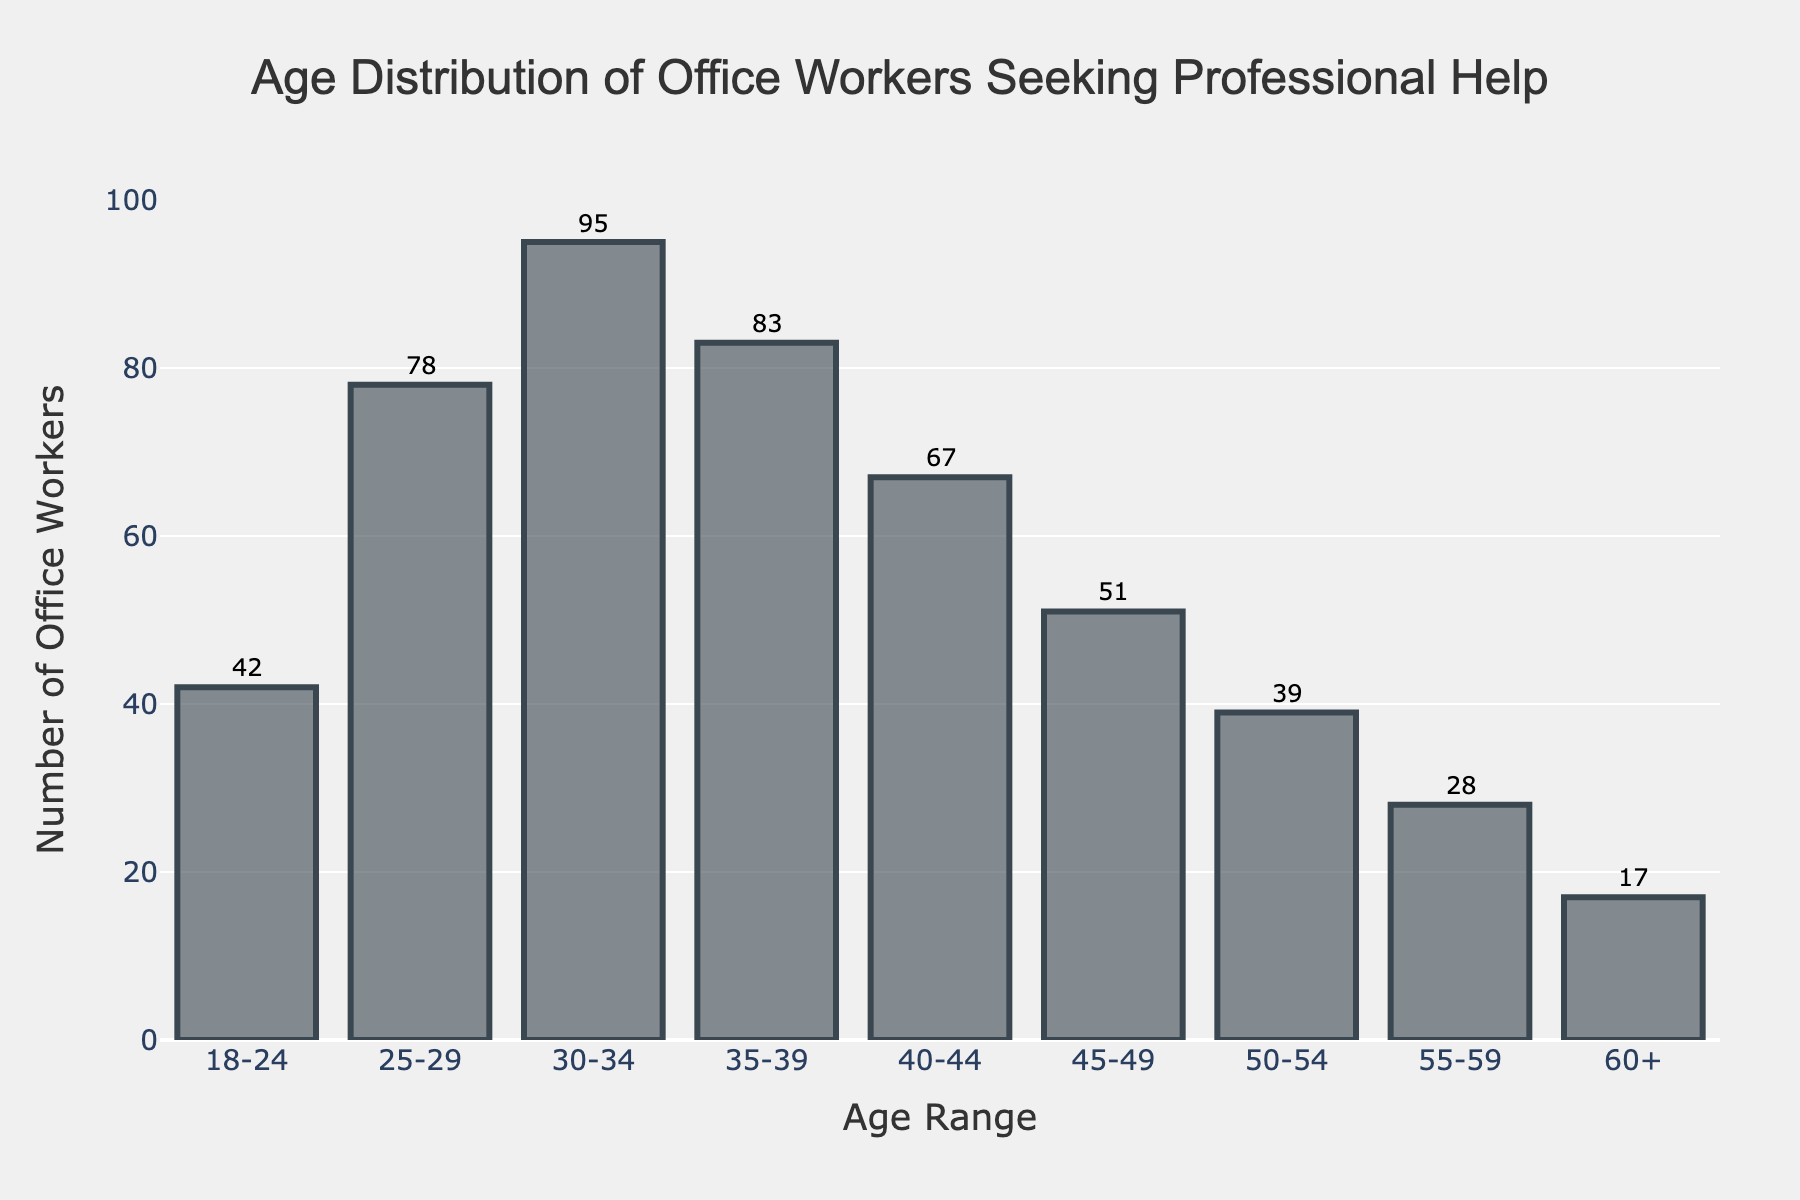What is the title of the histogram? The title of the histogram is displayed at the top of the figure, and it provides a brief description of what the chart represents.
Answer: Age Distribution of Office Workers Seeking Professional Help What is the age range with the highest number of office workers seeking professional help? By examining the heights of the bars in the histogram, we can identify the tallest bar, which corresponds to the age range with the most office workers. The 30-34 age range has the highest bar.
Answer: 30-34 How many office workers aged 25-29 are seeking professional help? Look at the bar corresponding to the 25-29 age range. The number at the top of this bar shows the count.
Answer: 78 Which age range has the least number of office workers seeking professional help? Find the shortest bar in the histogram to identify the age range with the fewest office workers. The 60+ age range has the shortest bar.
Answer: 60+ What is the total number of office workers seeking professional help for conflict resolution depicted in the histogram? Sum the values of all the bars to get the total number of office workers. \(42 + 78 + 95 + 83 + 67 + 51 + 39 + 28 + 17 = 500\)
Answer: 500 What is the difference in the number of office workers seeking professional help between the 30-34 and 40-44 age ranges? Subtract the number of office workers in the 40-44 age range from the number in the 30-34 age range. \(95 - 67 = 28\)
Answer: 28 Which age range has more office workers seeking help: 18-24 or 50-54? Compare the heights or the values of the bars for the 18-24 and 50-54 age ranges. The numbers at the top of the bars show these values. \(42 > 39\)
Answer: 18-24 What is the average number of office workers seeking professional help across all age ranges? Find the total number of office workers and divide by the number of age ranges. \(500 \div 9 \approx 55.56\)
Answer: 55.56 How does the number of office workers in the 45-49 age range compare to those in the 55-59 age range? Compare the heights or the values of the bars for the 45-49 and 55-59 age ranges. The numbers at the top of the bars show these values. \(51 > 28\)
Answer: 45-49 has more What is the median number of office workers seeking professional help among all age ranges? List all the numbers of office workers in ascending order and find the middle value. \(17, 28, 39, 42, 51, 67, 78, 83, 95\). The middle value is \(51\).
Answer: 51 